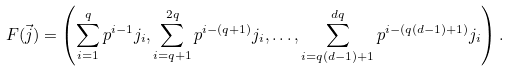<formula> <loc_0><loc_0><loc_500><loc_500>F ( \vec { j } ) = \left ( \sum _ { i = 1 } ^ { q } p ^ { i - 1 } j _ { i } , \sum _ { i = q + 1 } ^ { 2 q } p ^ { i - ( q + 1 ) } j _ { i } , \dots , \sum _ { i = q ( d - 1 ) + 1 } ^ { d q } p ^ { i - ( q ( d - 1 ) + 1 ) } j _ { i } \right ) .</formula> 